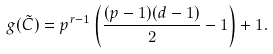Convert formula to latex. <formula><loc_0><loc_0><loc_500><loc_500>g ( \tilde { C } ) = p ^ { r - 1 } \left ( \frac { ( p - 1 ) ( d - 1 ) } { 2 } - 1 \right ) + 1 .</formula> 